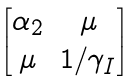<formula> <loc_0><loc_0><loc_500><loc_500>\begin{bmatrix} \alpha _ { 2 } & \mu \\ \mu & 1 / \gamma _ { I } \end{bmatrix}</formula> 